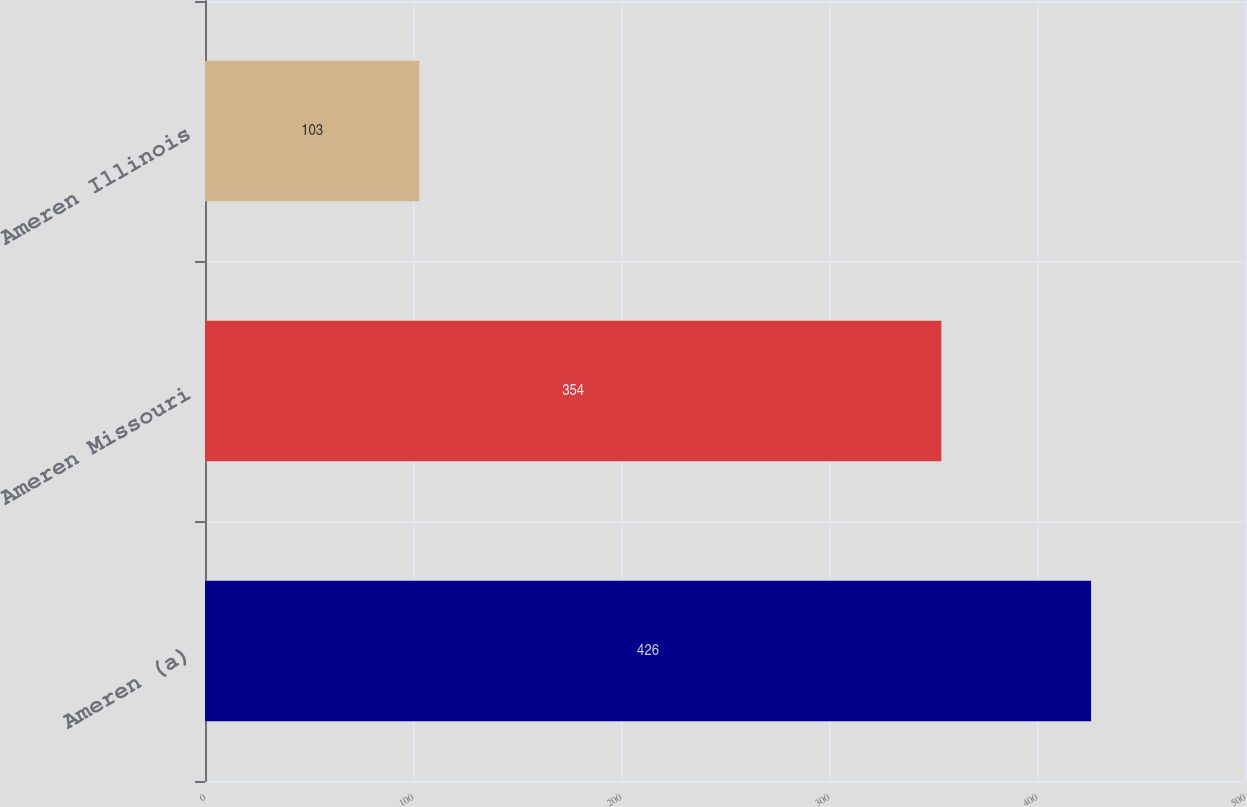Convert chart. <chart><loc_0><loc_0><loc_500><loc_500><bar_chart><fcel>Ameren (a)<fcel>Ameren Missouri<fcel>Ameren Illinois<nl><fcel>426<fcel>354<fcel>103<nl></chart> 